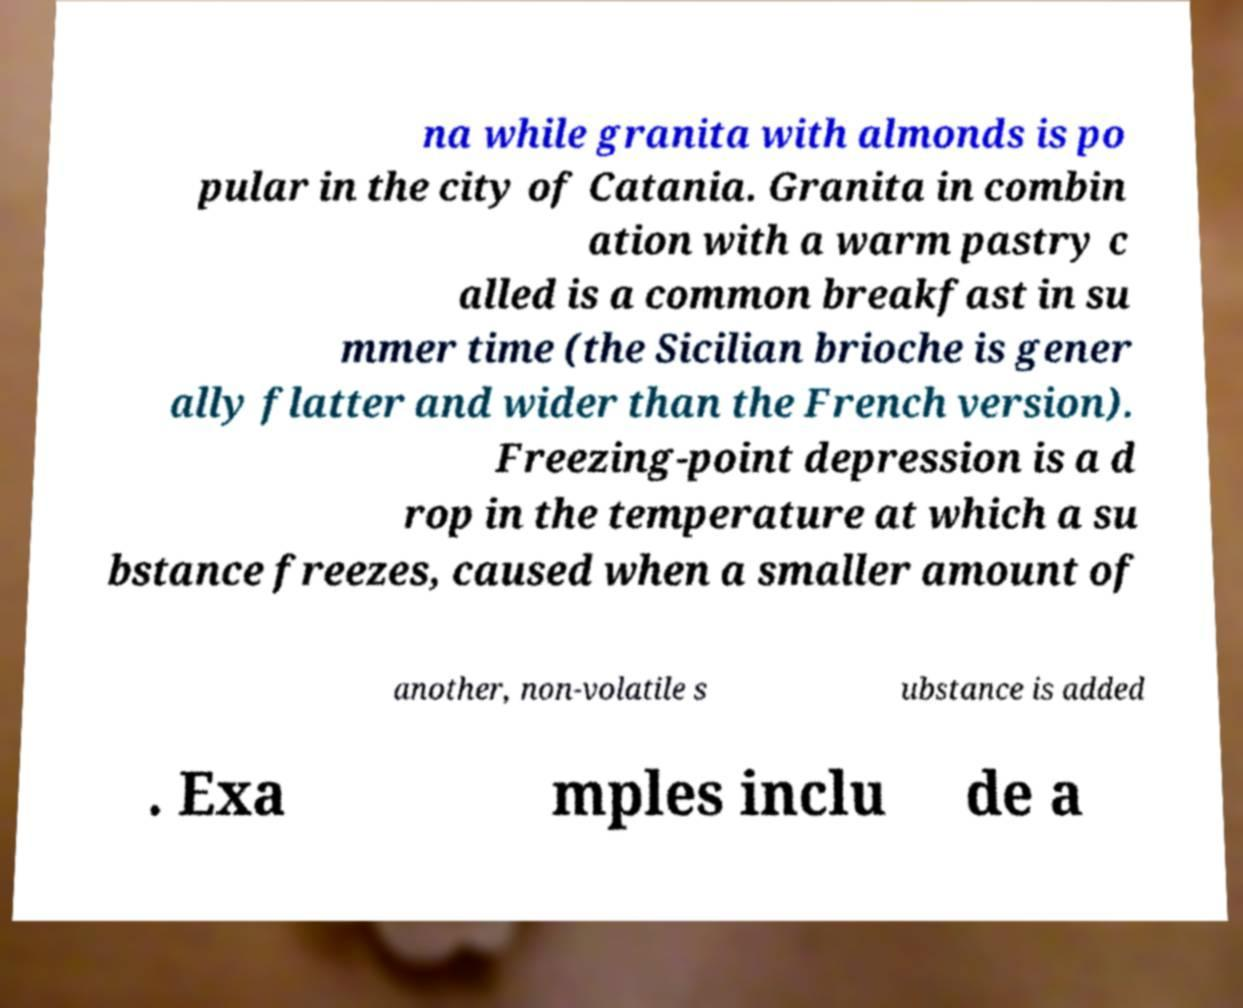There's text embedded in this image that I need extracted. Can you transcribe it verbatim? na while granita with almonds is po pular in the city of Catania. Granita in combin ation with a warm pastry c alled is a common breakfast in su mmer time (the Sicilian brioche is gener ally flatter and wider than the French version). Freezing-point depression is a d rop in the temperature at which a su bstance freezes, caused when a smaller amount of another, non-volatile s ubstance is added . Exa mples inclu de a 